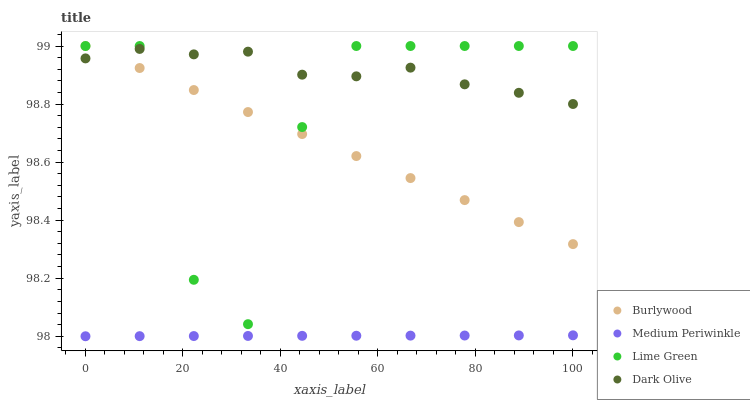Does Medium Periwinkle have the minimum area under the curve?
Answer yes or no. Yes. Does Dark Olive have the maximum area under the curve?
Answer yes or no. Yes. Does Lime Green have the minimum area under the curve?
Answer yes or no. No. Does Lime Green have the maximum area under the curve?
Answer yes or no. No. Is Medium Periwinkle the smoothest?
Answer yes or no. Yes. Is Lime Green the roughest?
Answer yes or no. Yes. Is Dark Olive the smoothest?
Answer yes or no. No. Is Dark Olive the roughest?
Answer yes or no. No. Does Medium Periwinkle have the lowest value?
Answer yes or no. Yes. Does Lime Green have the lowest value?
Answer yes or no. No. Does Lime Green have the highest value?
Answer yes or no. Yes. Does Dark Olive have the highest value?
Answer yes or no. No. Is Medium Periwinkle less than Dark Olive?
Answer yes or no. Yes. Is Dark Olive greater than Medium Periwinkle?
Answer yes or no. Yes. Does Dark Olive intersect Burlywood?
Answer yes or no. Yes. Is Dark Olive less than Burlywood?
Answer yes or no. No. Is Dark Olive greater than Burlywood?
Answer yes or no. No. Does Medium Periwinkle intersect Dark Olive?
Answer yes or no. No. 